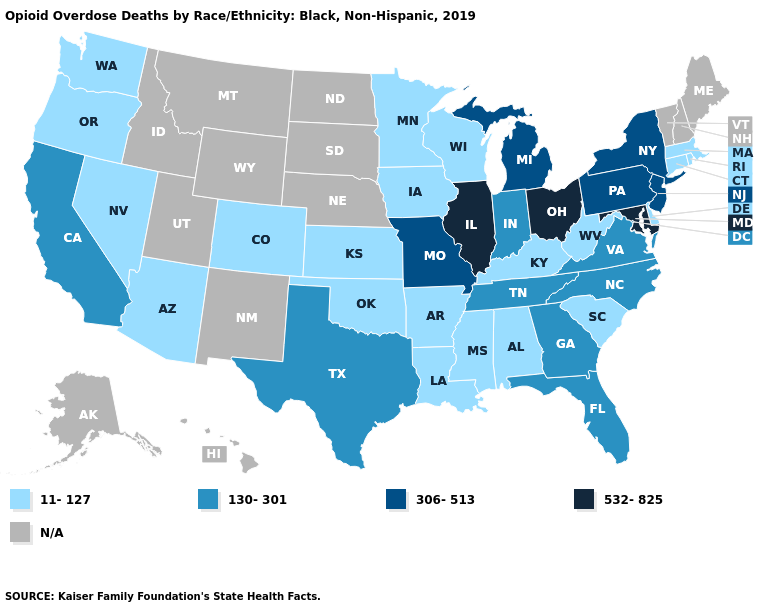Is the legend a continuous bar?
Be succinct. No. Name the states that have a value in the range N/A?
Quick response, please. Alaska, Hawaii, Idaho, Maine, Montana, Nebraska, New Hampshire, New Mexico, North Dakota, South Dakota, Utah, Vermont, Wyoming. What is the highest value in states that border Oklahoma?
Give a very brief answer. 306-513. Does Illinois have the highest value in the USA?
Concise answer only. Yes. Name the states that have a value in the range 306-513?
Give a very brief answer. Michigan, Missouri, New Jersey, New York, Pennsylvania. What is the value of Virginia?
Concise answer only. 130-301. What is the value of Minnesota?
Answer briefly. 11-127. Does New Jersey have the lowest value in the USA?
Keep it brief. No. Name the states that have a value in the range 11-127?
Short answer required. Alabama, Arizona, Arkansas, Colorado, Connecticut, Delaware, Iowa, Kansas, Kentucky, Louisiana, Massachusetts, Minnesota, Mississippi, Nevada, Oklahoma, Oregon, Rhode Island, South Carolina, Washington, West Virginia, Wisconsin. What is the lowest value in the USA?
Quick response, please. 11-127. Does Virginia have the lowest value in the South?
Be succinct. No. Among the states that border Wyoming , which have the lowest value?
Be succinct. Colorado. Name the states that have a value in the range N/A?
Answer briefly. Alaska, Hawaii, Idaho, Maine, Montana, Nebraska, New Hampshire, New Mexico, North Dakota, South Dakota, Utah, Vermont, Wyoming. Name the states that have a value in the range 11-127?
Concise answer only. Alabama, Arizona, Arkansas, Colorado, Connecticut, Delaware, Iowa, Kansas, Kentucky, Louisiana, Massachusetts, Minnesota, Mississippi, Nevada, Oklahoma, Oregon, Rhode Island, South Carolina, Washington, West Virginia, Wisconsin. 